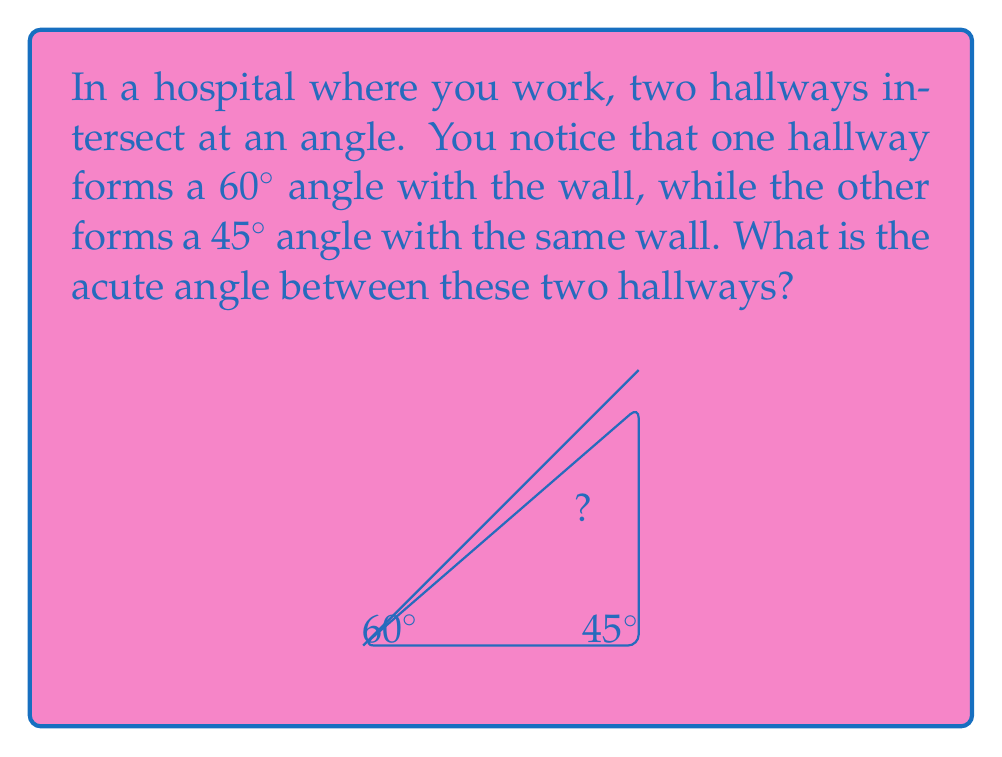Teach me how to tackle this problem. Let's approach this step-by-step:

1) First, let's visualize the problem. We have two hallways intersecting, and we know their angles relative to the wall.

2) The key here is to realize that the angle between the hallways is the difference between their angles relative to the wall.

3) We can express this mathematically:
   $$\text{Angle between hallways} = |\text{Angle of hallway 1} - \text{Angle of hallway 2}|$$

4) Plugging in our known values:
   $$\text{Angle between hallways} = |60^\circ - 45^\circ|$$

5) Calculating:
   $$\text{Angle between hallways} = 15^\circ$$

6) Note that we took the absolute value because we're interested in the acute angle between the hallways, regardless of which hallway we consider first.

Thus, the acute angle between the two hallways is $15^\circ$.
Answer: $15^\circ$ 